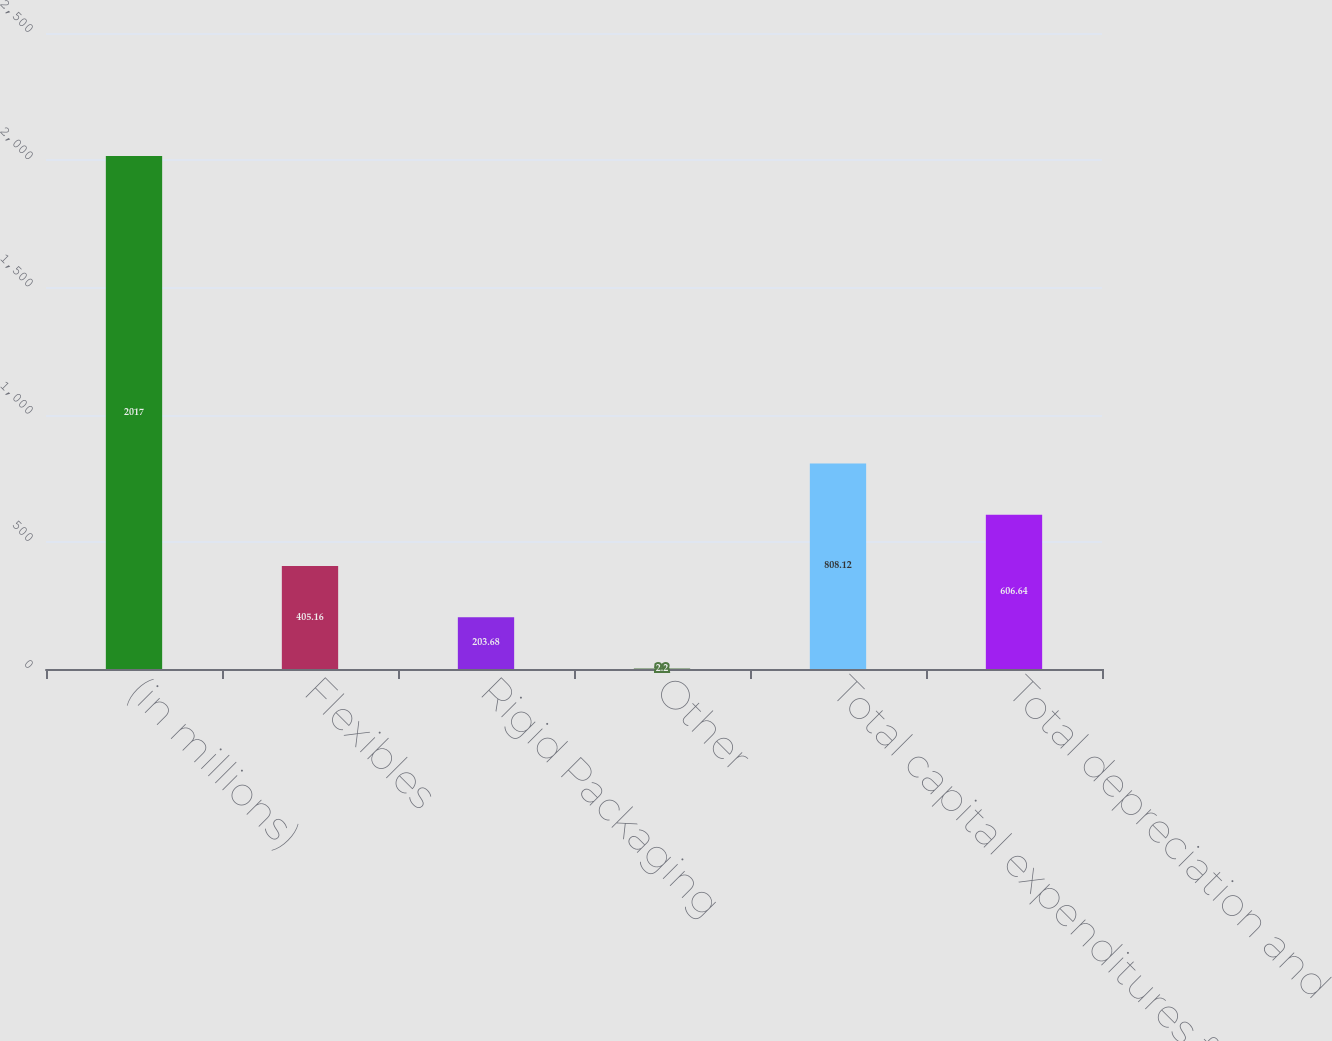<chart> <loc_0><loc_0><loc_500><loc_500><bar_chart><fcel>(in millions)<fcel>Flexibles<fcel>Rigid Packaging<fcel>Other<fcel>Total capital expenditures for<fcel>Total depreciation and<nl><fcel>2017<fcel>405.16<fcel>203.68<fcel>2.2<fcel>808.12<fcel>606.64<nl></chart> 